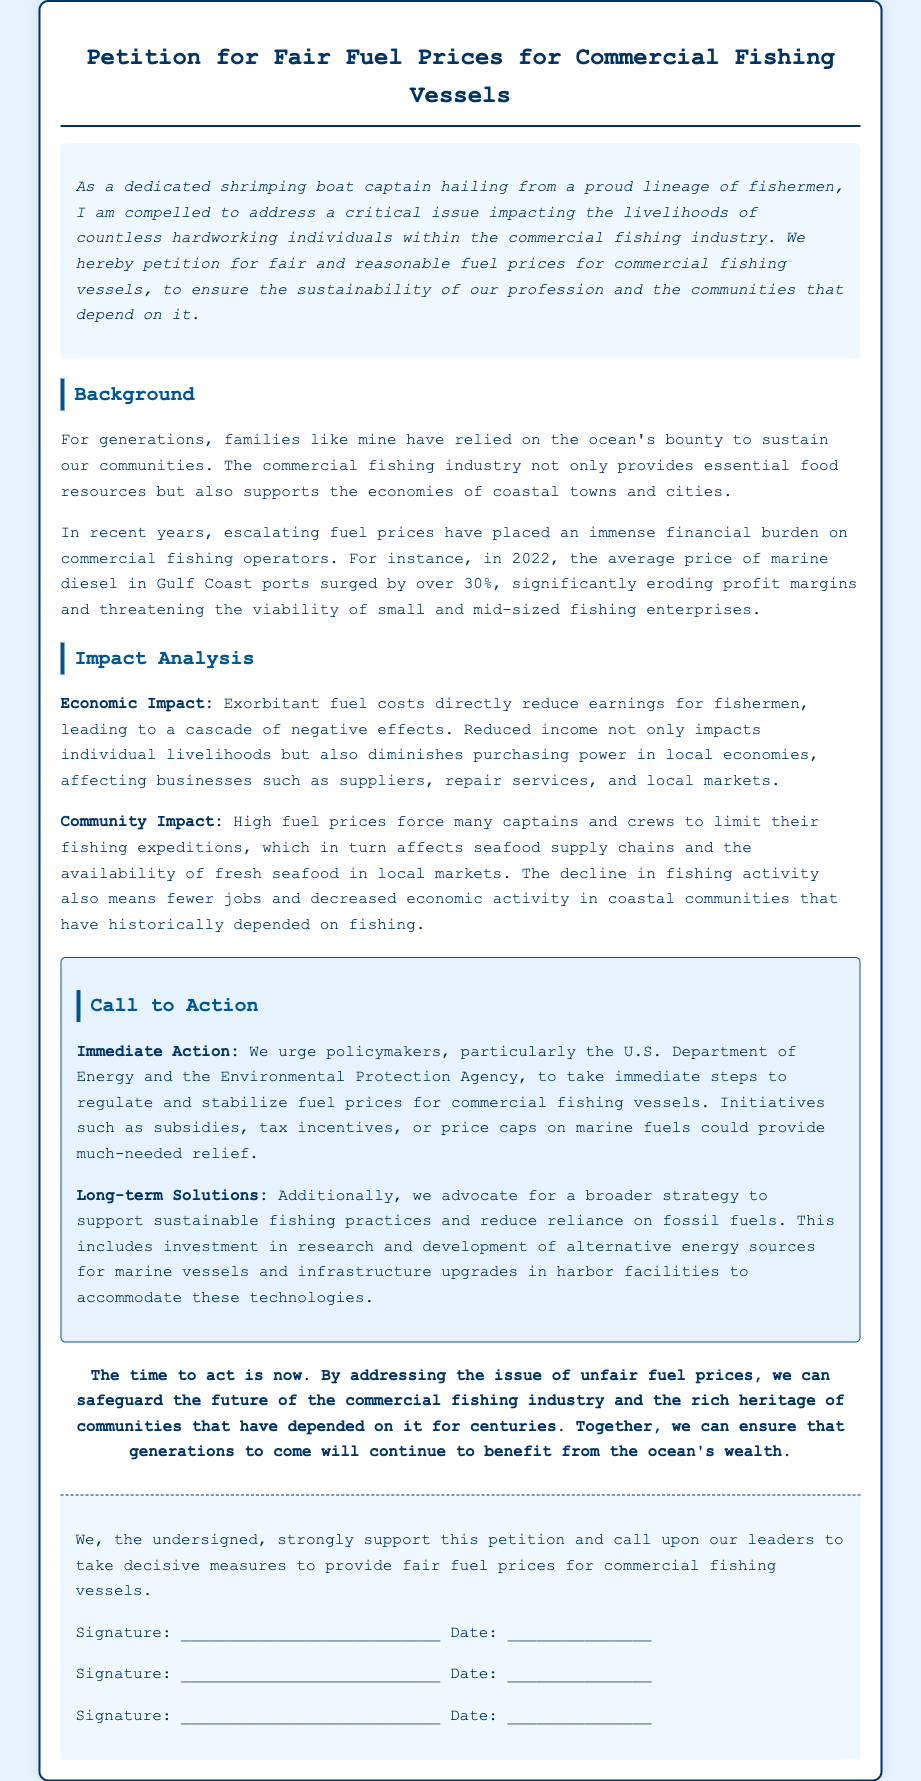What is the title of the petition? The title is prominently displayed at the top of the document.
Answer: Petition for Fair Fuel Prices for Commercial Fishing Vessels Who is the author identified in the introduction? The introduction describes the author's profession and lineage.
Answer: shrimping boat captain What was the percentage increase in marine diesel prices in 2022? The document provides a specific figure pertaining to fuel price changes.
Answer: over 30% What are the two main types of impacts analyzed in the document? The impacts are categorized clearly within the text.
Answer: Economic Impact and Community Impact Which two U.S. departments are urged to take action in the call to action? The document specifies the relevant policymakers to address this issue.
Answer: U.S. Department of Energy and Environmental Protection Agency What does the author suggest as a short-term solution? The call to action section lists possible immediate measures.
Answer: subsidies, tax incentives, or price caps What is the final message in the conclusion regarding the timing of actions? The conclusion emphasizes an urgency regarding the proposed actions.
Answer: The time to act is now What type of document is this? The content and intent classifies the document uniquely.
Answer: Petition 